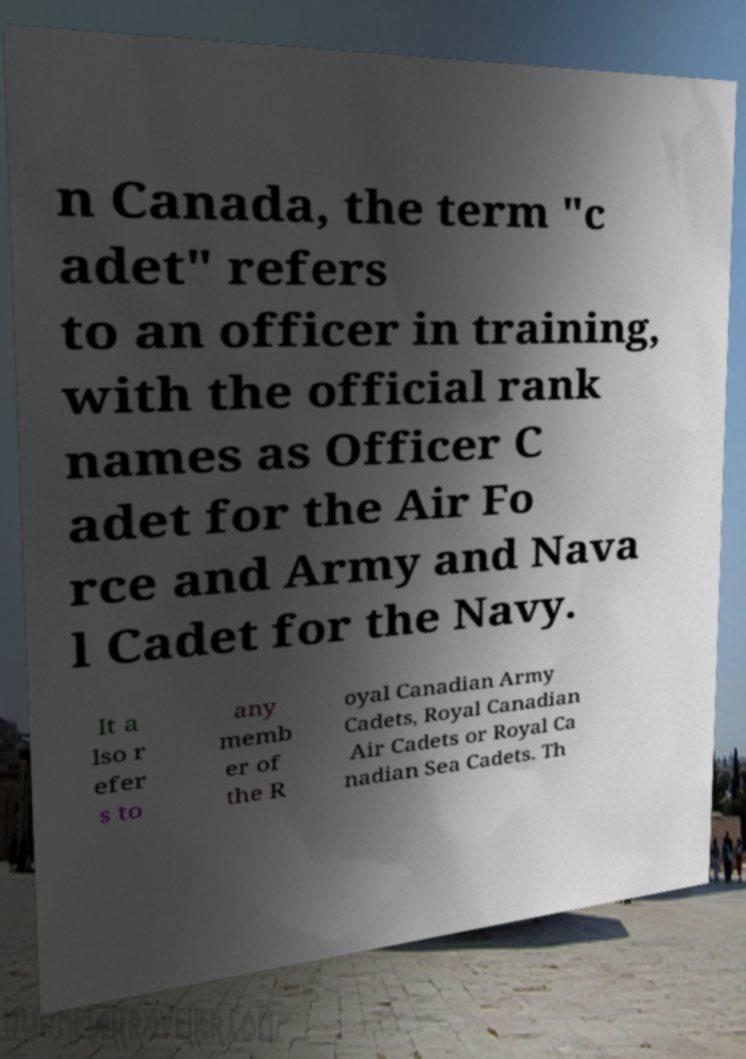Can you read and provide the text displayed in the image?This photo seems to have some interesting text. Can you extract and type it out for me? n Canada, the term "c adet" refers to an officer in training, with the official rank names as Officer C adet for the Air Fo rce and Army and Nava l Cadet for the Navy. It a lso r efer s to any memb er of the R oyal Canadian Army Cadets, Royal Canadian Air Cadets or Royal Ca nadian Sea Cadets. Th 